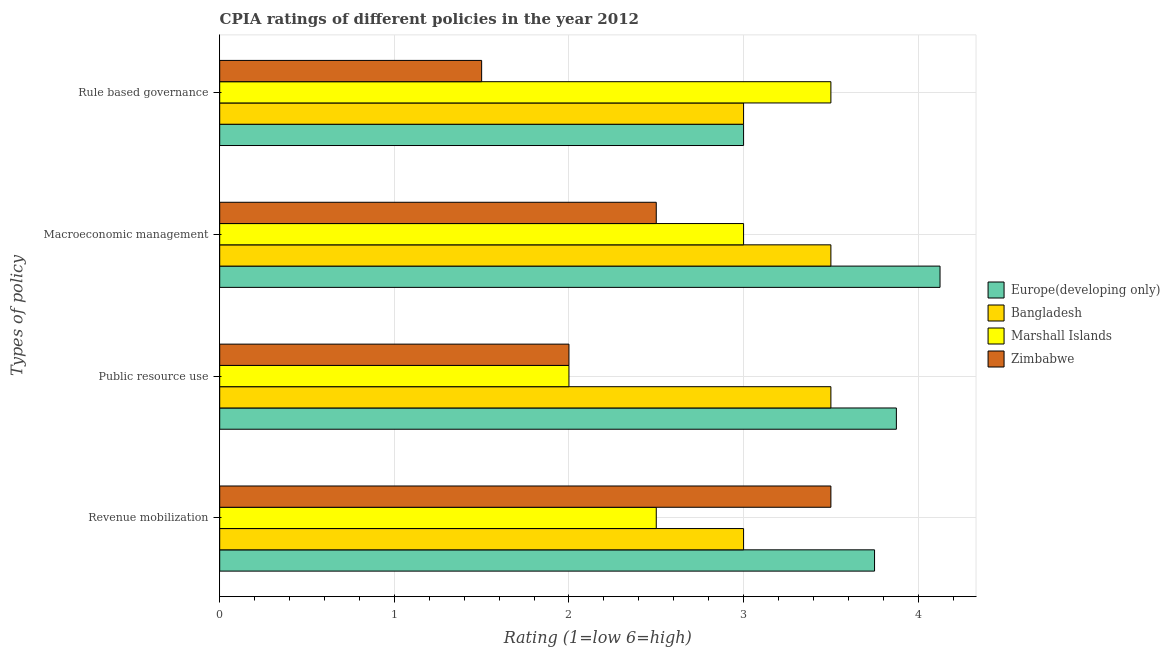How many groups of bars are there?
Your answer should be very brief. 4. Are the number of bars on each tick of the Y-axis equal?
Your answer should be very brief. Yes. How many bars are there on the 4th tick from the top?
Make the answer very short. 4. What is the label of the 4th group of bars from the top?
Offer a very short reply. Revenue mobilization. What is the cpia rating of rule based governance in Zimbabwe?
Your answer should be compact. 1.5. Across all countries, what is the maximum cpia rating of public resource use?
Keep it short and to the point. 3.88. In which country was the cpia rating of revenue mobilization maximum?
Make the answer very short. Europe(developing only). In which country was the cpia rating of public resource use minimum?
Ensure brevity in your answer.  Marshall Islands. What is the total cpia rating of public resource use in the graph?
Give a very brief answer. 11.38. What is the difference between the cpia rating of rule based governance in Europe(developing only) and the cpia rating of public resource use in Marshall Islands?
Provide a short and direct response. 1. What is the average cpia rating of public resource use per country?
Make the answer very short. 2.84. What is the difference between the cpia rating of rule based governance and cpia rating of revenue mobilization in Zimbabwe?
Give a very brief answer. -2. In how many countries, is the cpia rating of macroeconomic management greater than 3.8 ?
Provide a short and direct response. 1. What is the ratio of the cpia rating of rule based governance in Zimbabwe to that in Marshall Islands?
Offer a terse response. 0.43. Is the cpia rating of rule based governance in Europe(developing only) less than that in Zimbabwe?
Provide a succinct answer. No. What is the difference between the highest and the lowest cpia rating of public resource use?
Offer a terse response. 1.88. In how many countries, is the cpia rating of revenue mobilization greater than the average cpia rating of revenue mobilization taken over all countries?
Provide a succinct answer. 2. Is it the case that in every country, the sum of the cpia rating of revenue mobilization and cpia rating of public resource use is greater than the sum of cpia rating of macroeconomic management and cpia rating of rule based governance?
Your response must be concise. No. What does the 1st bar from the top in Rule based governance represents?
Offer a very short reply. Zimbabwe. What does the 4th bar from the bottom in Rule based governance represents?
Ensure brevity in your answer.  Zimbabwe. Are all the bars in the graph horizontal?
Your answer should be very brief. Yes. How many countries are there in the graph?
Offer a terse response. 4. Does the graph contain grids?
Make the answer very short. Yes. How are the legend labels stacked?
Ensure brevity in your answer.  Vertical. What is the title of the graph?
Keep it short and to the point. CPIA ratings of different policies in the year 2012. Does "World" appear as one of the legend labels in the graph?
Your response must be concise. No. What is the label or title of the X-axis?
Your answer should be very brief. Rating (1=low 6=high). What is the label or title of the Y-axis?
Your answer should be compact. Types of policy. What is the Rating (1=low 6=high) of Europe(developing only) in Revenue mobilization?
Your answer should be very brief. 3.75. What is the Rating (1=low 6=high) in Europe(developing only) in Public resource use?
Offer a terse response. 3.88. What is the Rating (1=low 6=high) in Bangladesh in Public resource use?
Offer a very short reply. 3.5. What is the Rating (1=low 6=high) of Marshall Islands in Public resource use?
Keep it short and to the point. 2. What is the Rating (1=low 6=high) in Zimbabwe in Public resource use?
Provide a short and direct response. 2. What is the Rating (1=low 6=high) in Europe(developing only) in Macroeconomic management?
Ensure brevity in your answer.  4.12. What is the Rating (1=low 6=high) of Europe(developing only) in Rule based governance?
Give a very brief answer. 3. What is the Rating (1=low 6=high) of Bangladesh in Rule based governance?
Ensure brevity in your answer.  3. What is the Rating (1=low 6=high) in Zimbabwe in Rule based governance?
Provide a succinct answer. 1.5. Across all Types of policy, what is the maximum Rating (1=low 6=high) of Europe(developing only)?
Your answer should be compact. 4.12. Across all Types of policy, what is the maximum Rating (1=low 6=high) of Zimbabwe?
Ensure brevity in your answer.  3.5. Across all Types of policy, what is the minimum Rating (1=low 6=high) of Europe(developing only)?
Your answer should be compact. 3. Across all Types of policy, what is the minimum Rating (1=low 6=high) in Marshall Islands?
Provide a succinct answer. 2. What is the total Rating (1=low 6=high) in Europe(developing only) in the graph?
Your answer should be very brief. 14.75. What is the total Rating (1=low 6=high) of Bangladesh in the graph?
Your response must be concise. 13. What is the difference between the Rating (1=low 6=high) in Europe(developing only) in Revenue mobilization and that in Public resource use?
Your response must be concise. -0.12. What is the difference between the Rating (1=low 6=high) in Marshall Islands in Revenue mobilization and that in Public resource use?
Your answer should be very brief. 0.5. What is the difference between the Rating (1=low 6=high) of Europe(developing only) in Revenue mobilization and that in Macroeconomic management?
Offer a terse response. -0.38. What is the difference between the Rating (1=low 6=high) in Europe(developing only) in Revenue mobilization and that in Rule based governance?
Your response must be concise. 0.75. What is the difference between the Rating (1=low 6=high) of Bangladesh in Revenue mobilization and that in Rule based governance?
Keep it short and to the point. 0. What is the difference between the Rating (1=low 6=high) in Marshall Islands in Revenue mobilization and that in Rule based governance?
Your response must be concise. -1. What is the difference between the Rating (1=low 6=high) in Europe(developing only) in Public resource use and that in Macroeconomic management?
Make the answer very short. -0.25. What is the difference between the Rating (1=low 6=high) of Bangladesh in Public resource use and that in Macroeconomic management?
Keep it short and to the point. 0. What is the difference between the Rating (1=low 6=high) in Marshall Islands in Public resource use and that in Macroeconomic management?
Provide a short and direct response. -1. What is the difference between the Rating (1=low 6=high) of Zimbabwe in Public resource use and that in Macroeconomic management?
Your answer should be very brief. -0.5. What is the difference between the Rating (1=low 6=high) of Zimbabwe in Public resource use and that in Rule based governance?
Your answer should be compact. 0.5. What is the difference between the Rating (1=low 6=high) in Bangladesh in Macroeconomic management and that in Rule based governance?
Keep it short and to the point. 0.5. What is the difference between the Rating (1=low 6=high) of Zimbabwe in Macroeconomic management and that in Rule based governance?
Offer a terse response. 1. What is the difference between the Rating (1=low 6=high) in Europe(developing only) in Revenue mobilization and the Rating (1=low 6=high) in Bangladesh in Public resource use?
Offer a terse response. 0.25. What is the difference between the Rating (1=low 6=high) in Marshall Islands in Revenue mobilization and the Rating (1=low 6=high) in Zimbabwe in Public resource use?
Your answer should be very brief. 0.5. What is the difference between the Rating (1=low 6=high) in Europe(developing only) in Revenue mobilization and the Rating (1=low 6=high) in Marshall Islands in Macroeconomic management?
Your answer should be very brief. 0.75. What is the difference between the Rating (1=low 6=high) of Bangladesh in Revenue mobilization and the Rating (1=low 6=high) of Marshall Islands in Macroeconomic management?
Your answer should be compact. 0. What is the difference between the Rating (1=low 6=high) in Europe(developing only) in Revenue mobilization and the Rating (1=low 6=high) in Zimbabwe in Rule based governance?
Offer a terse response. 2.25. What is the difference between the Rating (1=low 6=high) in Bangladesh in Revenue mobilization and the Rating (1=low 6=high) in Zimbabwe in Rule based governance?
Offer a terse response. 1.5. What is the difference between the Rating (1=low 6=high) of Marshall Islands in Revenue mobilization and the Rating (1=low 6=high) of Zimbabwe in Rule based governance?
Ensure brevity in your answer.  1. What is the difference between the Rating (1=low 6=high) of Europe(developing only) in Public resource use and the Rating (1=low 6=high) of Bangladesh in Macroeconomic management?
Make the answer very short. 0.38. What is the difference between the Rating (1=low 6=high) of Europe(developing only) in Public resource use and the Rating (1=low 6=high) of Marshall Islands in Macroeconomic management?
Your answer should be compact. 0.88. What is the difference between the Rating (1=low 6=high) of Europe(developing only) in Public resource use and the Rating (1=low 6=high) of Zimbabwe in Macroeconomic management?
Give a very brief answer. 1.38. What is the difference between the Rating (1=low 6=high) in Bangladesh in Public resource use and the Rating (1=low 6=high) in Zimbabwe in Macroeconomic management?
Your response must be concise. 1. What is the difference between the Rating (1=low 6=high) of Marshall Islands in Public resource use and the Rating (1=low 6=high) of Zimbabwe in Macroeconomic management?
Offer a very short reply. -0.5. What is the difference between the Rating (1=low 6=high) of Europe(developing only) in Public resource use and the Rating (1=low 6=high) of Bangladesh in Rule based governance?
Your answer should be very brief. 0.88. What is the difference between the Rating (1=low 6=high) of Europe(developing only) in Public resource use and the Rating (1=low 6=high) of Zimbabwe in Rule based governance?
Ensure brevity in your answer.  2.38. What is the difference between the Rating (1=low 6=high) in Bangladesh in Public resource use and the Rating (1=low 6=high) in Marshall Islands in Rule based governance?
Your response must be concise. 0. What is the difference between the Rating (1=low 6=high) in Bangladesh in Public resource use and the Rating (1=low 6=high) in Zimbabwe in Rule based governance?
Your answer should be compact. 2. What is the difference between the Rating (1=low 6=high) in Marshall Islands in Public resource use and the Rating (1=low 6=high) in Zimbabwe in Rule based governance?
Offer a very short reply. 0.5. What is the difference between the Rating (1=low 6=high) of Europe(developing only) in Macroeconomic management and the Rating (1=low 6=high) of Bangladesh in Rule based governance?
Your answer should be very brief. 1.12. What is the difference between the Rating (1=low 6=high) in Europe(developing only) in Macroeconomic management and the Rating (1=low 6=high) in Marshall Islands in Rule based governance?
Keep it short and to the point. 0.62. What is the difference between the Rating (1=low 6=high) of Europe(developing only) in Macroeconomic management and the Rating (1=low 6=high) of Zimbabwe in Rule based governance?
Your answer should be very brief. 2.62. What is the difference between the Rating (1=low 6=high) in Bangladesh in Macroeconomic management and the Rating (1=low 6=high) in Zimbabwe in Rule based governance?
Provide a succinct answer. 2. What is the difference between the Rating (1=low 6=high) of Marshall Islands in Macroeconomic management and the Rating (1=low 6=high) of Zimbabwe in Rule based governance?
Your answer should be very brief. 1.5. What is the average Rating (1=low 6=high) in Europe(developing only) per Types of policy?
Make the answer very short. 3.69. What is the average Rating (1=low 6=high) in Marshall Islands per Types of policy?
Your response must be concise. 2.75. What is the average Rating (1=low 6=high) of Zimbabwe per Types of policy?
Your response must be concise. 2.38. What is the difference between the Rating (1=low 6=high) of Europe(developing only) and Rating (1=low 6=high) of Bangladesh in Revenue mobilization?
Your response must be concise. 0.75. What is the difference between the Rating (1=low 6=high) of Europe(developing only) and Rating (1=low 6=high) of Marshall Islands in Revenue mobilization?
Your answer should be compact. 1.25. What is the difference between the Rating (1=low 6=high) in Bangladesh and Rating (1=low 6=high) in Marshall Islands in Revenue mobilization?
Offer a very short reply. 0.5. What is the difference between the Rating (1=low 6=high) in Bangladesh and Rating (1=low 6=high) in Zimbabwe in Revenue mobilization?
Provide a succinct answer. -0.5. What is the difference between the Rating (1=low 6=high) in Europe(developing only) and Rating (1=low 6=high) in Bangladesh in Public resource use?
Keep it short and to the point. 0.38. What is the difference between the Rating (1=low 6=high) in Europe(developing only) and Rating (1=low 6=high) in Marshall Islands in Public resource use?
Your answer should be very brief. 1.88. What is the difference between the Rating (1=low 6=high) in Europe(developing only) and Rating (1=low 6=high) in Zimbabwe in Public resource use?
Provide a succinct answer. 1.88. What is the difference between the Rating (1=low 6=high) of Bangladesh and Rating (1=low 6=high) of Zimbabwe in Public resource use?
Offer a very short reply. 1.5. What is the difference between the Rating (1=low 6=high) in Marshall Islands and Rating (1=low 6=high) in Zimbabwe in Public resource use?
Provide a short and direct response. 0. What is the difference between the Rating (1=low 6=high) in Europe(developing only) and Rating (1=low 6=high) in Bangladesh in Macroeconomic management?
Provide a succinct answer. 0.62. What is the difference between the Rating (1=low 6=high) in Europe(developing only) and Rating (1=low 6=high) in Marshall Islands in Macroeconomic management?
Provide a succinct answer. 1.12. What is the difference between the Rating (1=low 6=high) of Europe(developing only) and Rating (1=low 6=high) of Zimbabwe in Macroeconomic management?
Keep it short and to the point. 1.62. What is the difference between the Rating (1=low 6=high) in Bangladesh and Rating (1=low 6=high) in Marshall Islands in Macroeconomic management?
Provide a short and direct response. 0.5. What is the difference between the Rating (1=low 6=high) of Bangladesh and Rating (1=low 6=high) of Zimbabwe in Macroeconomic management?
Provide a short and direct response. 1. What is the difference between the Rating (1=low 6=high) of Marshall Islands and Rating (1=low 6=high) of Zimbabwe in Macroeconomic management?
Make the answer very short. 0.5. What is the difference between the Rating (1=low 6=high) of Europe(developing only) and Rating (1=low 6=high) of Marshall Islands in Rule based governance?
Keep it short and to the point. -0.5. What is the difference between the Rating (1=low 6=high) of Bangladesh and Rating (1=low 6=high) of Marshall Islands in Rule based governance?
Ensure brevity in your answer.  -0.5. What is the ratio of the Rating (1=low 6=high) in Marshall Islands in Revenue mobilization to that in Public resource use?
Ensure brevity in your answer.  1.25. What is the ratio of the Rating (1=low 6=high) of Europe(developing only) in Revenue mobilization to that in Macroeconomic management?
Your response must be concise. 0.91. What is the ratio of the Rating (1=low 6=high) in Marshall Islands in Revenue mobilization to that in Macroeconomic management?
Your response must be concise. 0.83. What is the ratio of the Rating (1=low 6=high) of Bangladesh in Revenue mobilization to that in Rule based governance?
Ensure brevity in your answer.  1. What is the ratio of the Rating (1=low 6=high) in Zimbabwe in Revenue mobilization to that in Rule based governance?
Ensure brevity in your answer.  2.33. What is the ratio of the Rating (1=low 6=high) in Europe(developing only) in Public resource use to that in Macroeconomic management?
Offer a very short reply. 0.94. What is the ratio of the Rating (1=low 6=high) in Marshall Islands in Public resource use to that in Macroeconomic management?
Offer a very short reply. 0.67. What is the ratio of the Rating (1=low 6=high) of Zimbabwe in Public resource use to that in Macroeconomic management?
Make the answer very short. 0.8. What is the ratio of the Rating (1=low 6=high) in Europe(developing only) in Public resource use to that in Rule based governance?
Offer a very short reply. 1.29. What is the ratio of the Rating (1=low 6=high) in Bangladesh in Public resource use to that in Rule based governance?
Your answer should be very brief. 1.17. What is the ratio of the Rating (1=low 6=high) of Europe(developing only) in Macroeconomic management to that in Rule based governance?
Provide a short and direct response. 1.38. What is the ratio of the Rating (1=low 6=high) in Zimbabwe in Macroeconomic management to that in Rule based governance?
Provide a succinct answer. 1.67. What is the difference between the highest and the second highest Rating (1=low 6=high) of Bangladesh?
Ensure brevity in your answer.  0. What is the difference between the highest and the second highest Rating (1=low 6=high) of Marshall Islands?
Give a very brief answer. 0.5. What is the difference between the highest and the second highest Rating (1=low 6=high) in Zimbabwe?
Provide a short and direct response. 1. What is the difference between the highest and the lowest Rating (1=low 6=high) in Bangladesh?
Your answer should be very brief. 0.5. What is the difference between the highest and the lowest Rating (1=low 6=high) in Marshall Islands?
Provide a succinct answer. 1.5. What is the difference between the highest and the lowest Rating (1=low 6=high) of Zimbabwe?
Offer a very short reply. 2. 